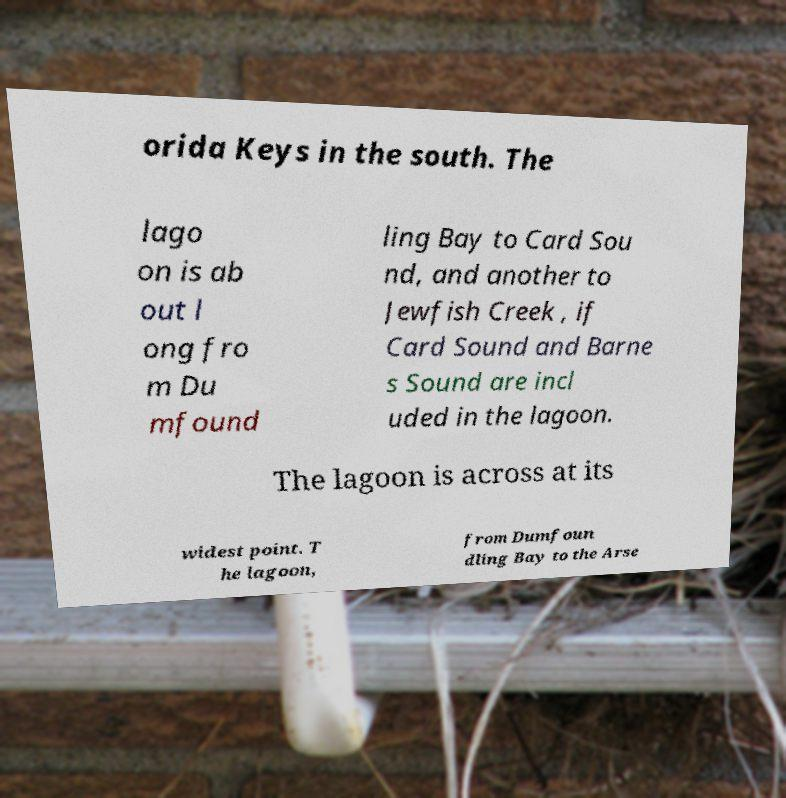I need the written content from this picture converted into text. Can you do that? orida Keys in the south. The lago on is ab out l ong fro m Du mfound ling Bay to Card Sou nd, and another to Jewfish Creek , if Card Sound and Barne s Sound are incl uded in the lagoon. The lagoon is across at its widest point. T he lagoon, from Dumfoun dling Bay to the Arse 